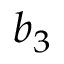<formula> <loc_0><loc_0><loc_500><loc_500>b _ { 3 }</formula> 